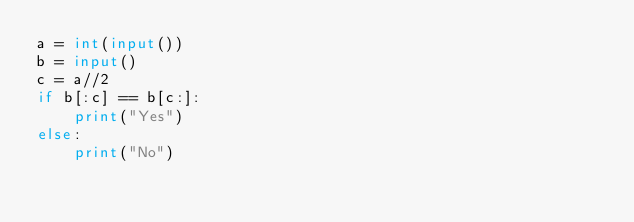Convert code to text. <code><loc_0><loc_0><loc_500><loc_500><_Python_>a = int(input())
b = input()
c = a//2
if b[:c] == b[c:]:
    print("Yes")
else:
    print("No")</code> 